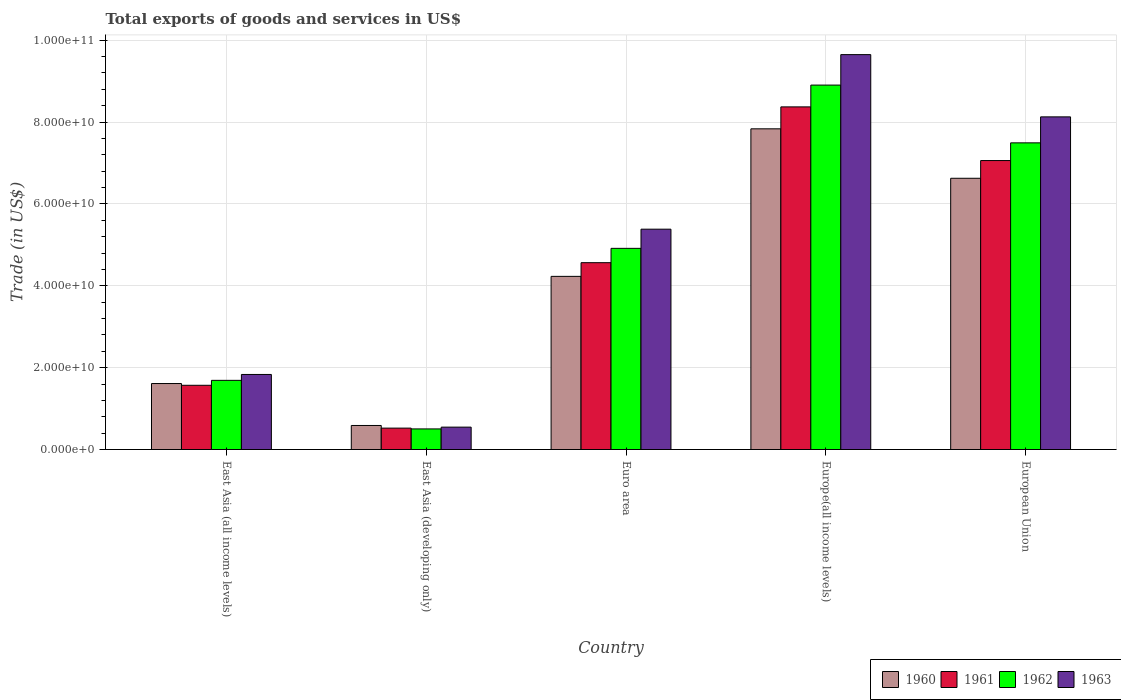How many groups of bars are there?
Offer a terse response. 5. Are the number of bars per tick equal to the number of legend labels?
Make the answer very short. Yes. Are the number of bars on each tick of the X-axis equal?
Provide a short and direct response. Yes. How many bars are there on the 3rd tick from the left?
Give a very brief answer. 4. What is the label of the 5th group of bars from the left?
Give a very brief answer. European Union. In how many cases, is the number of bars for a given country not equal to the number of legend labels?
Offer a very short reply. 0. What is the total exports of goods and services in 1963 in European Union?
Ensure brevity in your answer.  8.13e+1. Across all countries, what is the maximum total exports of goods and services in 1962?
Your response must be concise. 8.90e+1. Across all countries, what is the minimum total exports of goods and services in 1962?
Ensure brevity in your answer.  5.03e+09. In which country was the total exports of goods and services in 1962 maximum?
Your response must be concise. Europe(all income levels). In which country was the total exports of goods and services in 1960 minimum?
Make the answer very short. East Asia (developing only). What is the total total exports of goods and services in 1963 in the graph?
Offer a terse response. 2.55e+11. What is the difference between the total exports of goods and services in 1963 in East Asia (developing only) and that in Euro area?
Your response must be concise. -4.84e+1. What is the difference between the total exports of goods and services in 1961 in East Asia (developing only) and the total exports of goods and services in 1962 in East Asia (all income levels)?
Offer a very short reply. -1.17e+1. What is the average total exports of goods and services in 1960 per country?
Offer a very short reply. 4.18e+1. What is the difference between the total exports of goods and services of/in 1960 and total exports of goods and services of/in 1961 in Europe(all income levels)?
Your answer should be very brief. -5.36e+09. In how many countries, is the total exports of goods and services in 1960 greater than 56000000000 US$?
Make the answer very short. 2. What is the ratio of the total exports of goods and services in 1963 in East Asia (developing only) to that in European Union?
Make the answer very short. 0.07. Is the difference between the total exports of goods and services in 1960 in Euro area and Europe(all income levels) greater than the difference between the total exports of goods and services in 1961 in Euro area and Europe(all income levels)?
Your answer should be compact. Yes. What is the difference between the highest and the second highest total exports of goods and services in 1962?
Give a very brief answer. -3.99e+1. What is the difference between the highest and the lowest total exports of goods and services in 1961?
Ensure brevity in your answer.  7.85e+1. Is the sum of the total exports of goods and services in 1963 in East Asia (all income levels) and Europe(all income levels) greater than the maximum total exports of goods and services in 1962 across all countries?
Make the answer very short. Yes. Is it the case that in every country, the sum of the total exports of goods and services in 1962 and total exports of goods and services in 1961 is greater than the sum of total exports of goods and services in 1960 and total exports of goods and services in 1963?
Give a very brief answer. No. What does the 4th bar from the left in Europe(all income levels) represents?
Your answer should be compact. 1963. What does the 4th bar from the right in East Asia (developing only) represents?
Make the answer very short. 1960. Is it the case that in every country, the sum of the total exports of goods and services in 1960 and total exports of goods and services in 1961 is greater than the total exports of goods and services in 1962?
Your response must be concise. Yes. Are all the bars in the graph horizontal?
Ensure brevity in your answer.  No. How many countries are there in the graph?
Keep it short and to the point. 5. What is the difference between two consecutive major ticks on the Y-axis?
Provide a short and direct response. 2.00e+1. Does the graph contain grids?
Your answer should be compact. Yes. Where does the legend appear in the graph?
Offer a terse response. Bottom right. How many legend labels are there?
Make the answer very short. 4. What is the title of the graph?
Your answer should be very brief. Total exports of goods and services in US$. What is the label or title of the X-axis?
Your response must be concise. Country. What is the label or title of the Y-axis?
Make the answer very short. Trade (in US$). What is the Trade (in US$) in 1960 in East Asia (all income levels)?
Your answer should be very brief. 1.61e+1. What is the Trade (in US$) of 1961 in East Asia (all income levels)?
Provide a short and direct response. 1.57e+1. What is the Trade (in US$) in 1962 in East Asia (all income levels)?
Give a very brief answer. 1.69e+1. What is the Trade (in US$) in 1963 in East Asia (all income levels)?
Your response must be concise. 1.83e+1. What is the Trade (in US$) in 1960 in East Asia (developing only)?
Offer a very short reply. 5.87e+09. What is the Trade (in US$) of 1961 in East Asia (developing only)?
Keep it short and to the point. 5.23e+09. What is the Trade (in US$) in 1962 in East Asia (developing only)?
Offer a very short reply. 5.03e+09. What is the Trade (in US$) in 1963 in East Asia (developing only)?
Provide a succinct answer. 5.47e+09. What is the Trade (in US$) of 1960 in Euro area?
Provide a succinct answer. 4.23e+1. What is the Trade (in US$) in 1961 in Euro area?
Provide a succinct answer. 4.56e+1. What is the Trade (in US$) of 1962 in Euro area?
Ensure brevity in your answer.  4.91e+1. What is the Trade (in US$) of 1963 in Euro area?
Keep it short and to the point. 5.38e+1. What is the Trade (in US$) of 1960 in Europe(all income levels)?
Make the answer very short. 7.83e+1. What is the Trade (in US$) in 1961 in Europe(all income levels)?
Ensure brevity in your answer.  8.37e+1. What is the Trade (in US$) of 1962 in Europe(all income levels)?
Provide a short and direct response. 8.90e+1. What is the Trade (in US$) in 1963 in Europe(all income levels)?
Give a very brief answer. 9.65e+1. What is the Trade (in US$) of 1960 in European Union?
Keep it short and to the point. 6.63e+1. What is the Trade (in US$) in 1961 in European Union?
Give a very brief answer. 7.06e+1. What is the Trade (in US$) in 1962 in European Union?
Offer a very short reply. 7.49e+1. What is the Trade (in US$) in 1963 in European Union?
Your answer should be compact. 8.13e+1. Across all countries, what is the maximum Trade (in US$) of 1960?
Keep it short and to the point. 7.83e+1. Across all countries, what is the maximum Trade (in US$) in 1961?
Keep it short and to the point. 8.37e+1. Across all countries, what is the maximum Trade (in US$) in 1962?
Your response must be concise. 8.90e+1. Across all countries, what is the maximum Trade (in US$) of 1963?
Ensure brevity in your answer.  9.65e+1. Across all countries, what is the minimum Trade (in US$) of 1960?
Offer a terse response. 5.87e+09. Across all countries, what is the minimum Trade (in US$) in 1961?
Provide a succinct answer. 5.23e+09. Across all countries, what is the minimum Trade (in US$) of 1962?
Make the answer very short. 5.03e+09. Across all countries, what is the minimum Trade (in US$) of 1963?
Your response must be concise. 5.47e+09. What is the total Trade (in US$) of 1960 in the graph?
Ensure brevity in your answer.  2.09e+11. What is the total Trade (in US$) in 1961 in the graph?
Your answer should be very brief. 2.21e+11. What is the total Trade (in US$) of 1962 in the graph?
Your response must be concise. 2.35e+11. What is the total Trade (in US$) in 1963 in the graph?
Provide a succinct answer. 2.55e+11. What is the difference between the Trade (in US$) in 1960 in East Asia (all income levels) and that in East Asia (developing only)?
Your answer should be compact. 1.02e+1. What is the difference between the Trade (in US$) in 1961 in East Asia (all income levels) and that in East Asia (developing only)?
Ensure brevity in your answer.  1.05e+1. What is the difference between the Trade (in US$) of 1962 in East Asia (all income levels) and that in East Asia (developing only)?
Offer a terse response. 1.19e+1. What is the difference between the Trade (in US$) in 1963 in East Asia (all income levels) and that in East Asia (developing only)?
Your response must be concise. 1.29e+1. What is the difference between the Trade (in US$) in 1960 in East Asia (all income levels) and that in Euro area?
Your response must be concise. -2.62e+1. What is the difference between the Trade (in US$) in 1961 in East Asia (all income levels) and that in Euro area?
Offer a terse response. -3.00e+1. What is the difference between the Trade (in US$) in 1962 in East Asia (all income levels) and that in Euro area?
Keep it short and to the point. -3.22e+1. What is the difference between the Trade (in US$) of 1963 in East Asia (all income levels) and that in Euro area?
Keep it short and to the point. -3.55e+1. What is the difference between the Trade (in US$) in 1960 in East Asia (all income levels) and that in Europe(all income levels)?
Your answer should be compact. -6.22e+1. What is the difference between the Trade (in US$) in 1961 in East Asia (all income levels) and that in Europe(all income levels)?
Offer a terse response. -6.80e+1. What is the difference between the Trade (in US$) in 1962 in East Asia (all income levels) and that in Europe(all income levels)?
Your answer should be compact. -7.21e+1. What is the difference between the Trade (in US$) of 1963 in East Asia (all income levels) and that in Europe(all income levels)?
Provide a succinct answer. -7.81e+1. What is the difference between the Trade (in US$) of 1960 in East Asia (all income levels) and that in European Union?
Ensure brevity in your answer.  -5.01e+1. What is the difference between the Trade (in US$) in 1961 in East Asia (all income levels) and that in European Union?
Offer a terse response. -5.49e+1. What is the difference between the Trade (in US$) of 1962 in East Asia (all income levels) and that in European Union?
Ensure brevity in your answer.  -5.80e+1. What is the difference between the Trade (in US$) in 1963 in East Asia (all income levels) and that in European Union?
Offer a terse response. -6.29e+1. What is the difference between the Trade (in US$) of 1960 in East Asia (developing only) and that in Euro area?
Your answer should be very brief. -3.64e+1. What is the difference between the Trade (in US$) of 1961 in East Asia (developing only) and that in Euro area?
Offer a very short reply. -4.04e+1. What is the difference between the Trade (in US$) of 1962 in East Asia (developing only) and that in Euro area?
Keep it short and to the point. -4.41e+1. What is the difference between the Trade (in US$) of 1963 in East Asia (developing only) and that in Euro area?
Make the answer very short. -4.84e+1. What is the difference between the Trade (in US$) of 1960 in East Asia (developing only) and that in Europe(all income levels)?
Your response must be concise. -7.25e+1. What is the difference between the Trade (in US$) of 1961 in East Asia (developing only) and that in Europe(all income levels)?
Ensure brevity in your answer.  -7.85e+1. What is the difference between the Trade (in US$) of 1962 in East Asia (developing only) and that in Europe(all income levels)?
Ensure brevity in your answer.  -8.40e+1. What is the difference between the Trade (in US$) of 1963 in East Asia (developing only) and that in Europe(all income levels)?
Offer a very short reply. -9.10e+1. What is the difference between the Trade (in US$) of 1960 in East Asia (developing only) and that in European Union?
Your response must be concise. -6.04e+1. What is the difference between the Trade (in US$) in 1961 in East Asia (developing only) and that in European Union?
Your answer should be very brief. -6.54e+1. What is the difference between the Trade (in US$) of 1962 in East Asia (developing only) and that in European Union?
Your answer should be very brief. -6.99e+1. What is the difference between the Trade (in US$) in 1963 in East Asia (developing only) and that in European Union?
Your answer should be compact. -7.58e+1. What is the difference between the Trade (in US$) of 1960 in Euro area and that in Europe(all income levels)?
Your response must be concise. -3.60e+1. What is the difference between the Trade (in US$) in 1961 in Euro area and that in Europe(all income levels)?
Make the answer very short. -3.81e+1. What is the difference between the Trade (in US$) of 1962 in Euro area and that in Europe(all income levels)?
Ensure brevity in your answer.  -3.99e+1. What is the difference between the Trade (in US$) of 1963 in Euro area and that in Europe(all income levels)?
Offer a very short reply. -4.26e+1. What is the difference between the Trade (in US$) of 1960 in Euro area and that in European Union?
Provide a short and direct response. -2.40e+1. What is the difference between the Trade (in US$) in 1961 in Euro area and that in European Union?
Offer a terse response. -2.49e+1. What is the difference between the Trade (in US$) of 1962 in Euro area and that in European Union?
Your answer should be very brief. -2.58e+1. What is the difference between the Trade (in US$) of 1963 in Euro area and that in European Union?
Make the answer very short. -2.74e+1. What is the difference between the Trade (in US$) of 1960 in Europe(all income levels) and that in European Union?
Your answer should be very brief. 1.21e+1. What is the difference between the Trade (in US$) of 1961 in Europe(all income levels) and that in European Union?
Provide a succinct answer. 1.31e+1. What is the difference between the Trade (in US$) in 1962 in Europe(all income levels) and that in European Union?
Ensure brevity in your answer.  1.41e+1. What is the difference between the Trade (in US$) of 1963 in Europe(all income levels) and that in European Union?
Provide a succinct answer. 1.52e+1. What is the difference between the Trade (in US$) in 1960 in East Asia (all income levels) and the Trade (in US$) in 1961 in East Asia (developing only)?
Your response must be concise. 1.09e+1. What is the difference between the Trade (in US$) of 1960 in East Asia (all income levels) and the Trade (in US$) of 1962 in East Asia (developing only)?
Your answer should be very brief. 1.11e+1. What is the difference between the Trade (in US$) in 1960 in East Asia (all income levels) and the Trade (in US$) in 1963 in East Asia (developing only)?
Give a very brief answer. 1.06e+1. What is the difference between the Trade (in US$) of 1961 in East Asia (all income levels) and the Trade (in US$) of 1962 in East Asia (developing only)?
Provide a succinct answer. 1.07e+1. What is the difference between the Trade (in US$) of 1961 in East Asia (all income levels) and the Trade (in US$) of 1963 in East Asia (developing only)?
Keep it short and to the point. 1.02e+1. What is the difference between the Trade (in US$) in 1962 in East Asia (all income levels) and the Trade (in US$) in 1963 in East Asia (developing only)?
Your response must be concise. 1.14e+1. What is the difference between the Trade (in US$) of 1960 in East Asia (all income levels) and the Trade (in US$) of 1961 in Euro area?
Ensure brevity in your answer.  -2.95e+1. What is the difference between the Trade (in US$) in 1960 in East Asia (all income levels) and the Trade (in US$) in 1962 in Euro area?
Offer a terse response. -3.30e+1. What is the difference between the Trade (in US$) of 1960 in East Asia (all income levels) and the Trade (in US$) of 1963 in Euro area?
Provide a succinct answer. -3.77e+1. What is the difference between the Trade (in US$) of 1961 in East Asia (all income levels) and the Trade (in US$) of 1962 in Euro area?
Provide a short and direct response. -3.34e+1. What is the difference between the Trade (in US$) of 1961 in East Asia (all income levels) and the Trade (in US$) of 1963 in Euro area?
Ensure brevity in your answer.  -3.81e+1. What is the difference between the Trade (in US$) in 1962 in East Asia (all income levels) and the Trade (in US$) in 1963 in Euro area?
Provide a succinct answer. -3.69e+1. What is the difference between the Trade (in US$) of 1960 in East Asia (all income levels) and the Trade (in US$) of 1961 in Europe(all income levels)?
Offer a very short reply. -6.76e+1. What is the difference between the Trade (in US$) of 1960 in East Asia (all income levels) and the Trade (in US$) of 1962 in Europe(all income levels)?
Provide a succinct answer. -7.29e+1. What is the difference between the Trade (in US$) of 1960 in East Asia (all income levels) and the Trade (in US$) of 1963 in Europe(all income levels)?
Make the answer very short. -8.03e+1. What is the difference between the Trade (in US$) of 1961 in East Asia (all income levels) and the Trade (in US$) of 1962 in Europe(all income levels)?
Keep it short and to the point. -7.33e+1. What is the difference between the Trade (in US$) of 1961 in East Asia (all income levels) and the Trade (in US$) of 1963 in Europe(all income levels)?
Your answer should be compact. -8.08e+1. What is the difference between the Trade (in US$) in 1962 in East Asia (all income levels) and the Trade (in US$) in 1963 in Europe(all income levels)?
Give a very brief answer. -7.96e+1. What is the difference between the Trade (in US$) in 1960 in East Asia (all income levels) and the Trade (in US$) in 1961 in European Union?
Your answer should be very brief. -5.45e+1. What is the difference between the Trade (in US$) of 1960 in East Asia (all income levels) and the Trade (in US$) of 1962 in European Union?
Give a very brief answer. -5.88e+1. What is the difference between the Trade (in US$) of 1960 in East Asia (all income levels) and the Trade (in US$) of 1963 in European Union?
Ensure brevity in your answer.  -6.51e+1. What is the difference between the Trade (in US$) in 1961 in East Asia (all income levels) and the Trade (in US$) in 1962 in European Union?
Keep it short and to the point. -5.92e+1. What is the difference between the Trade (in US$) of 1961 in East Asia (all income levels) and the Trade (in US$) of 1963 in European Union?
Offer a very short reply. -6.56e+1. What is the difference between the Trade (in US$) in 1962 in East Asia (all income levels) and the Trade (in US$) in 1963 in European Union?
Your answer should be compact. -6.44e+1. What is the difference between the Trade (in US$) in 1960 in East Asia (developing only) and the Trade (in US$) in 1961 in Euro area?
Offer a terse response. -3.98e+1. What is the difference between the Trade (in US$) of 1960 in East Asia (developing only) and the Trade (in US$) of 1962 in Euro area?
Make the answer very short. -4.33e+1. What is the difference between the Trade (in US$) of 1960 in East Asia (developing only) and the Trade (in US$) of 1963 in Euro area?
Make the answer very short. -4.79e+1. What is the difference between the Trade (in US$) of 1961 in East Asia (developing only) and the Trade (in US$) of 1962 in Euro area?
Your response must be concise. -4.39e+1. What is the difference between the Trade (in US$) of 1961 in East Asia (developing only) and the Trade (in US$) of 1963 in Euro area?
Provide a short and direct response. -4.86e+1. What is the difference between the Trade (in US$) of 1962 in East Asia (developing only) and the Trade (in US$) of 1963 in Euro area?
Ensure brevity in your answer.  -4.88e+1. What is the difference between the Trade (in US$) of 1960 in East Asia (developing only) and the Trade (in US$) of 1961 in Europe(all income levels)?
Your response must be concise. -7.78e+1. What is the difference between the Trade (in US$) in 1960 in East Asia (developing only) and the Trade (in US$) in 1962 in Europe(all income levels)?
Your answer should be very brief. -8.31e+1. What is the difference between the Trade (in US$) in 1960 in East Asia (developing only) and the Trade (in US$) in 1963 in Europe(all income levels)?
Provide a short and direct response. -9.06e+1. What is the difference between the Trade (in US$) in 1961 in East Asia (developing only) and the Trade (in US$) in 1962 in Europe(all income levels)?
Offer a terse response. -8.38e+1. What is the difference between the Trade (in US$) of 1961 in East Asia (developing only) and the Trade (in US$) of 1963 in Europe(all income levels)?
Provide a short and direct response. -9.12e+1. What is the difference between the Trade (in US$) of 1962 in East Asia (developing only) and the Trade (in US$) of 1963 in Europe(all income levels)?
Offer a terse response. -9.14e+1. What is the difference between the Trade (in US$) of 1960 in East Asia (developing only) and the Trade (in US$) of 1961 in European Union?
Your answer should be very brief. -6.47e+1. What is the difference between the Trade (in US$) of 1960 in East Asia (developing only) and the Trade (in US$) of 1962 in European Union?
Ensure brevity in your answer.  -6.90e+1. What is the difference between the Trade (in US$) of 1960 in East Asia (developing only) and the Trade (in US$) of 1963 in European Union?
Offer a very short reply. -7.54e+1. What is the difference between the Trade (in US$) of 1961 in East Asia (developing only) and the Trade (in US$) of 1962 in European Union?
Provide a succinct answer. -6.97e+1. What is the difference between the Trade (in US$) of 1961 in East Asia (developing only) and the Trade (in US$) of 1963 in European Union?
Keep it short and to the point. -7.60e+1. What is the difference between the Trade (in US$) in 1962 in East Asia (developing only) and the Trade (in US$) in 1963 in European Union?
Keep it short and to the point. -7.62e+1. What is the difference between the Trade (in US$) in 1960 in Euro area and the Trade (in US$) in 1961 in Europe(all income levels)?
Offer a very short reply. -4.14e+1. What is the difference between the Trade (in US$) in 1960 in Euro area and the Trade (in US$) in 1962 in Europe(all income levels)?
Ensure brevity in your answer.  -4.67e+1. What is the difference between the Trade (in US$) of 1960 in Euro area and the Trade (in US$) of 1963 in Europe(all income levels)?
Provide a succinct answer. -5.42e+1. What is the difference between the Trade (in US$) of 1961 in Euro area and the Trade (in US$) of 1962 in Europe(all income levels)?
Ensure brevity in your answer.  -4.34e+1. What is the difference between the Trade (in US$) of 1961 in Euro area and the Trade (in US$) of 1963 in Europe(all income levels)?
Your answer should be very brief. -5.08e+1. What is the difference between the Trade (in US$) of 1962 in Euro area and the Trade (in US$) of 1963 in Europe(all income levels)?
Offer a very short reply. -4.73e+1. What is the difference between the Trade (in US$) of 1960 in Euro area and the Trade (in US$) of 1961 in European Union?
Offer a very short reply. -2.83e+1. What is the difference between the Trade (in US$) of 1960 in Euro area and the Trade (in US$) of 1962 in European Union?
Your response must be concise. -3.26e+1. What is the difference between the Trade (in US$) of 1960 in Euro area and the Trade (in US$) of 1963 in European Union?
Provide a short and direct response. -3.90e+1. What is the difference between the Trade (in US$) in 1961 in Euro area and the Trade (in US$) in 1962 in European Union?
Make the answer very short. -2.93e+1. What is the difference between the Trade (in US$) of 1961 in Euro area and the Trade (in US$) of 1963 in European Union?
Your response must be concise. -3.56e+1. What is the difference between the Trade (in US$) of 1962 in Euro area and the Trade (in US$) of 1963 in European Union?
Make the answer very short. -3.21e+1. What is the difference between the Trade (in US$) in 1960 in Europe(all income levels) and the Trade (in US$) in 1961 in European Union?
Keep it short and to the point. 7.75e+09. What is the difference between the Trade (in US$) in 1960 in Europe(all income levels) and the Trade (in US$) in 1962 in European Union?
Ensure brevity in your answer.  3.43e+09. What is the difference between the Trade (in US$) in 1960 in Europe(all income levels) and the Trade (in US$) in 1963 in European Union?
Provide a short and direct response. -2.92e+09. What is the difference between the Trade (in US$) in 1961 in Europe(all income levels) and the Trade (in US$) in 1962 in European Union?
Provide a short and direct response. 8.79e+09. What is the difference between the Trade (in US$) in 1961 in Europe(all income levels) and the Trade (in US$) in 1963 in European Union?
Your answer should be compact. 2.44e+09. What is the difference between the Trade (in US$) in 1962 in Europe(all income levels) and the Trade (in US$) in 1963 in European Union?
Give a very brief answer. 7.76e+09. What is the average Trade (in US$) of 1960 per country?
Your response must be concise. 4.18e+1. What is the average Trade (in US$) in 1961 per country?
Make the answer very short. 4.42e+1. What is the average Trade (in US$) of 1962 per country?
Provide a succinct answer. 4.70e+1. What is the average Trade (in US$) in 1963 per country?
Your response must be concise. 5.11e+1. What is the difference between the Trade (in US$) in 1960 and Trade (in US$) in 1961 in East Asia (all income levels)?
Keep it short and to the point. 4.27e+08. What is the difference between the Trade (in US$) in 1960 and Trade (in US$) in 1962 in East Asia (all income levels)?
Your answer should be compact. -7.78e+08. What is the difference between the Trade (in US$) in 1960 and Trade (in US$) in 1963 in East Asia (all income levels)?
Give a very brief answer. -2.22e+09. What is the difference between the Trade (in US$) in 1961 and Trade (in US$) in 1962 in East Asia (all income levels)?
Offer a very short reply. -1.20e+09. What is the difference between the Trade (in US$) of 1961 and Trade (in US$) of 1963 in East Asia (all income levels)?
Provide a succinct answer. -2.64e+09. What is the difference between the Trade (in US$) of 1962 and Trade (in US$) of 1963 in East Asia (all income levels)?
Offer a very short reply. -1.44e+09. What is the difference between the Trade (in US$) in 1960 and Trade (in US$) in 1961 in East Asia (developing only)?
Provide a short and direct response. 6.45e+08. What is the difference between the Trade (in US$) of 1960 and Trade (in US$) of 1962 in East Asia (developing only)?
Make the answer very short. 8.39e+08. What is the difference between the Trade (in US$) of 1960 and Trade (in US$) of 1963 in East Asia (developing only)?
Provide a short and direct response. 4.04e+08. What is the difference between the Trade (in US$) in 1961 and Trade (in US$) in 1962 in East Asia (developing only)?
Provide a succinct answer. 1.95e+08. What is the difference between the Trade (in US$) in 1961 and Trade (in US$) in 1963 in East Asia (developing only)?
Your response must be concise. -2.41e+08. What is the difference between the Trade (in US$) of 1962 and Trade (in US$) of 1963 in East Asia (developing only)?
Ensure brevity in your answer.  -4.36e+08. What is the difference between the Trade (in US$) in 1960 and Trade (in US$) in 1961 in Euro area?
Your response must be concise. -3.34e+09. What is the difference between the Trade (in US$) in 1960 and Trade (in US$) in 1962 in Euro area?
Your response must be concise. -6.84e+09. What is the difference between the Trade (in US$) in 1960 and Trade (in US$) in 1963 in Euro area?
Offer a terse response. -1.15e+1. What is the difference between the Trade (in US$) in 1961 and Trade (in US$) in 1962 in Euro area?
Your response must be concise. -3.50e+09. What is the difference between the Trade (in US$) in 1961 and Trade (in US$) in 1963 in Euro area?
Give a very brief answer. -8.18e+09. What is the difference between the Trade (in US$) of 1962 and Trade (in US$) of 1963 in Euro area?
Make the answer very short. -4.68e+09. What is the difference between the Trade (in US$) in 1960 and Trade (in US$) in 1961 in Europe(all income levels)?
Your answer should be compact. -5.36e+09. What is the difference between the Trade (in US$) in 1960 and Trade (in US$) in 1962 in Europe(all income levels)?
Give a very brief answer. -1.07e+1. What is the difference between the Trade (in US$) in 1960 and Trade (in US$) in 1963 in Europe(all income levels)?
Ensure brevity in your answer.  -1.81e+1. What is the difference between the Trade (in US$) in 1961 and Trade (in US$) in 1962 in Europe(all income levels)?
Provide a succinct answer. -5.33e+09. What is the difference between the Trade (in US$) of 1961 and Trade (in US$) of 1963 in Europe(all income levels)?
Give a very brief answer. -1.28e+1. What is the difference between the Trade (in US$) in 1962 and Trade (in US$) in 1963 in Europe(all income levels)?
Provide a succinct answer. -7.44e+09. What is the difference between the Trade (in US$) of 1960 and Trade (in US$) of 1961 in European Union?
Your response must be concise. -4.33e+09. What is the difference between the Trade (in US$) in 1960 and Trade (in US$) in 1962 in European Union?
Offer a terse response. -8.65e+09. What is the difference between the Trade (in US$) in 1960 and Trade (in US$) in 1963 in European Union?
Provide a succinct answer. -1.50e+1. What is the difference between the Trade (in US$) in 1961 and Trade (in US$) in 1962 in European Union?
Make the answer very short. -4.32e+09. What is the difference between the Trade (in US$) in 1961 and Trade (in US$) in 1963 in European Union?
Offer a very short reply. -1.07e+1. What is the difference between the Trade (in US$) in 1962 and Trade (in US$) in 1963 in European Union?
Keep it short and to the point. -6.35e+09. What is the ratio of the Trade (in US$) of 1960 in East Asia (all income levels) to that in East Asia (developing only)?
Provide a short and direct response. 2.74. What is the ratio of the Trade (in US$) of 1961 in East Asia (all income levels) to that in East Asia (developing only)?
Make the answer very short. 3. What is the ratio of the Trade (in US$) in 1962 in East Asia (all income levels) to that in East Asia (developing only)?
Ensure brevity in your answer.  3.36. What is the ratio of the Trade (in US$) in 1963 in East Asia (all income levels) to that in East Asia (developing only)?
Provide a short and direct response. 3.35. What is the ratio of the Trade (in US$) in 1960 in East Asia (all income levels) to that in Euro area?
Keep it short and to the point. 0.38. What is the ratio of the Trade (in US$) of 1961 in East Asia (all income levels) to that in Euro area?
Keep it short and to the point. 0.34. What is the ratio of the Trade (in US$) in 1962 in East Asia (all income levels) to that in Euro area?
Your answer should be very brief. 0.34. What is the ratio of the Trade (in US$) in 1963 in East Asia (all income levels) to that in Euro area?
Your response must be concise. 0.34. What is the ratio of the Trade (in US$) in 1960 in East Asia (all income levels) to that in Europe(all income levels)?
Give a very brief answer. 0.21. What is the ratio of the Trade (in US$) of 1961 in East Asia (all income levels) to that in Europe(all income levels)?
Provide a short and direct response. 0.19. What is the ratio of the Trade (in US$) of 1962 in East Asia (all income levels) to that in Europe(all income levels)?
Provide a short and direct response. 0.19. What is the ratio of the Trade (in US$) in 1963 in East Asia (all income levels) to that in Europe(all income levels)?
Keep it short and to the point. 0.19. What is the ratio of the Trade (in US$) of 1960 in East Asia (all income levels) to that in European Union?
Your answer should be very brief. 0.24. What is the ratio of the Trade (in US$) in 1961 in East Asia (all income levels) to that in European Union?
Your response must be concise. 0.22. What is the ratio of the Trade (in US$) of 1962 in East Asia (all income levels) to that in European Union?
Your answer should be compact. 0.23. What is the ratio of the Trade (in US$) of 1963 in East Asia (all income levels) to that in European Union?
Offer a terse response. 0.23. What is the ratio of the Trade (in US$) in 1960 in East Asia (developing only) to that in Euro area?
Provide a succinct answer. 0.14. What is the ratio of the Trade (in US$) in 1961 in East Asia (developing only) to that in Euro area?
Keep it short and to the point. 0.11. What is the ratio of the Trade (in US$) of 1962 in East Asia (developing only) to that in Euro area?
Your response must be concise. 0.1. What is the ratio of the Trade (in US$) in 1963 in East Asia (developing only) to that in Euro area?
Provide a short and direct response. 0.1. What is the ratio of the Trade (in US$) of 1960 in East Asia (developing only) to that in Europe(all income levels)?
Ensure brevity in your answer.  0.07. What is the ratio of the Trade (in US$) of 1961 in East Asia (developing only) to that in Europe(all income levels)?
Make the answer very short. 0.06. What is the ratio of the Trade (in US$) of 1962 in East Asia (developing only) to that in Europe(all income levels)?
Offer a terse response. 0.06. What is the ratio of the Trade (in US$) of 1963 in East Asia (developing only) to that in Europe(all income levels)?
Your answer should be compact. 0.06. What is the ratio of the Trade (in US$) in 1960 in East Asia (developing only) to that in European Union?
Offer a terse response. 0.09. What is the ratio of the Trade (in US$) of 1961 in East Asia (developing only) to that in European Union?
Keep it short and to the point. 0.07. What is the ratio of the Trade (in US$) of 1962 in East Asia (developing only) to that in European Union?
Provide a succinct answer. 0.07. What is the ratio of the Trade (in US$) of 1963 in East Asia (developing only) to that in European Union?
Keep it short and to the point. 0.07. What is the ratio of the Trade (in US$) in 1960 in Euro area to that in Europe(all income levels)?
Your answer should be very brief. 0.54. What is the ratio of the Trade (in US$) of 1961 in Euro area to that in Europe(all income levels)?
Provide a succinct answer. 0.55. What is the ratio of the Trade (in US$) of 1962 in Euro area to that in Europe(all income levels)?
Your response must be concise. 0.55. What is the ratio of the Trade (in US$) of 1963 in Euro area to that in Europe(all income levels)?
Provide a succinct answer. 0.56. What is the ratio of the Trade (in US$) of 1960 in Euro area to that in European Union?
Ensure brevity in your answer.  0.64. What is the ratio of the Trade (in US$) in 1961 in Euro area to that in European Union?
Give a very brief answer. 0.65. What is the ratio of the Trade (in US$) of 1962 in Euro area to that in European Union?
Provide a short and direct response. 0.66. What is the ratio of the Trade (in US$) of 1963 in Euro area to that in European Union?
Give a very brief answer. 0.66. What is the ratio of the Trade (in US$) of 1960 in Europe(all income levels) to that in European Union?
Provide a short and direct response. 1.18. What is the ratio of the Trade (in US$) of 1961 in Europe(all income levels) to that in European Union?
Keep it short and to the point. 1.19. What is the ratio of the Trade (in US$) of 1962 in Europe(all income levels) to that in European Union?
Provide a succinct answer. 1.19. What is the ratio of the Trade (in US$) in 1963 in Europe(all income levels) to that in European Union?
Ensure brevity in your answer.  1.19. What is the difference between the highest and the second highest Trade (in US$) of 1960?
Offer a very short reply. 1.21e+1. What is the difference between the highest and the second highest Trade (in US$) in 1961?
Your answer should be compact. 1.31e+1. What is the difference between the highest and the second highest Trade (in US$) in 1962?
Your answer should be very brief. 1.41e+1. What is the difference between the highest and the second highest Trade (in US$) in 1963?
Give a very brief answer. 1.52e+1. What is the difference between the highest and the lowest Trade (in US$) of 1960?
Keep it short and to the point. 7.25e+1. What is the difference between the highest and the lowest Trade (in US$) of 1961?
Provide a succinct answer. 7.85e+1. What is the difference between the highest and the lowest Trade (in US$) of 1962?
Give a very brief answer. 8.40e+1. What is the difference between the highest and the lowest Trade (in US$) of 1963?
Keep it short and to the point. 9.10e+1. 